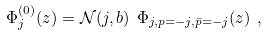Convert formula to latex. <formula><loc_0><loc_0><loc_500><loc_500>\Phi _ { j } ^ { ( 0 ) } ( z ) = \mathcal { N } ( j , b ) \ \Phi _ { j , p = - j , \bar { p } = - j } ( z ) \ ,</formula> 